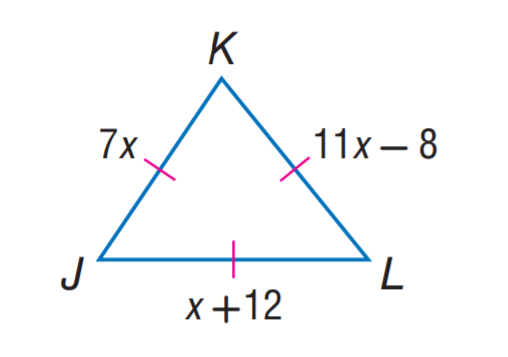Question: Find J K.
Choices:
A. 7
B. 11
C. 12
D. 14
Answer with the letter. Answer: D Question: Find K L.
Choices:
A. 7
B. 11
C. 12
D. 14
Answer with the letter. Answer: D 